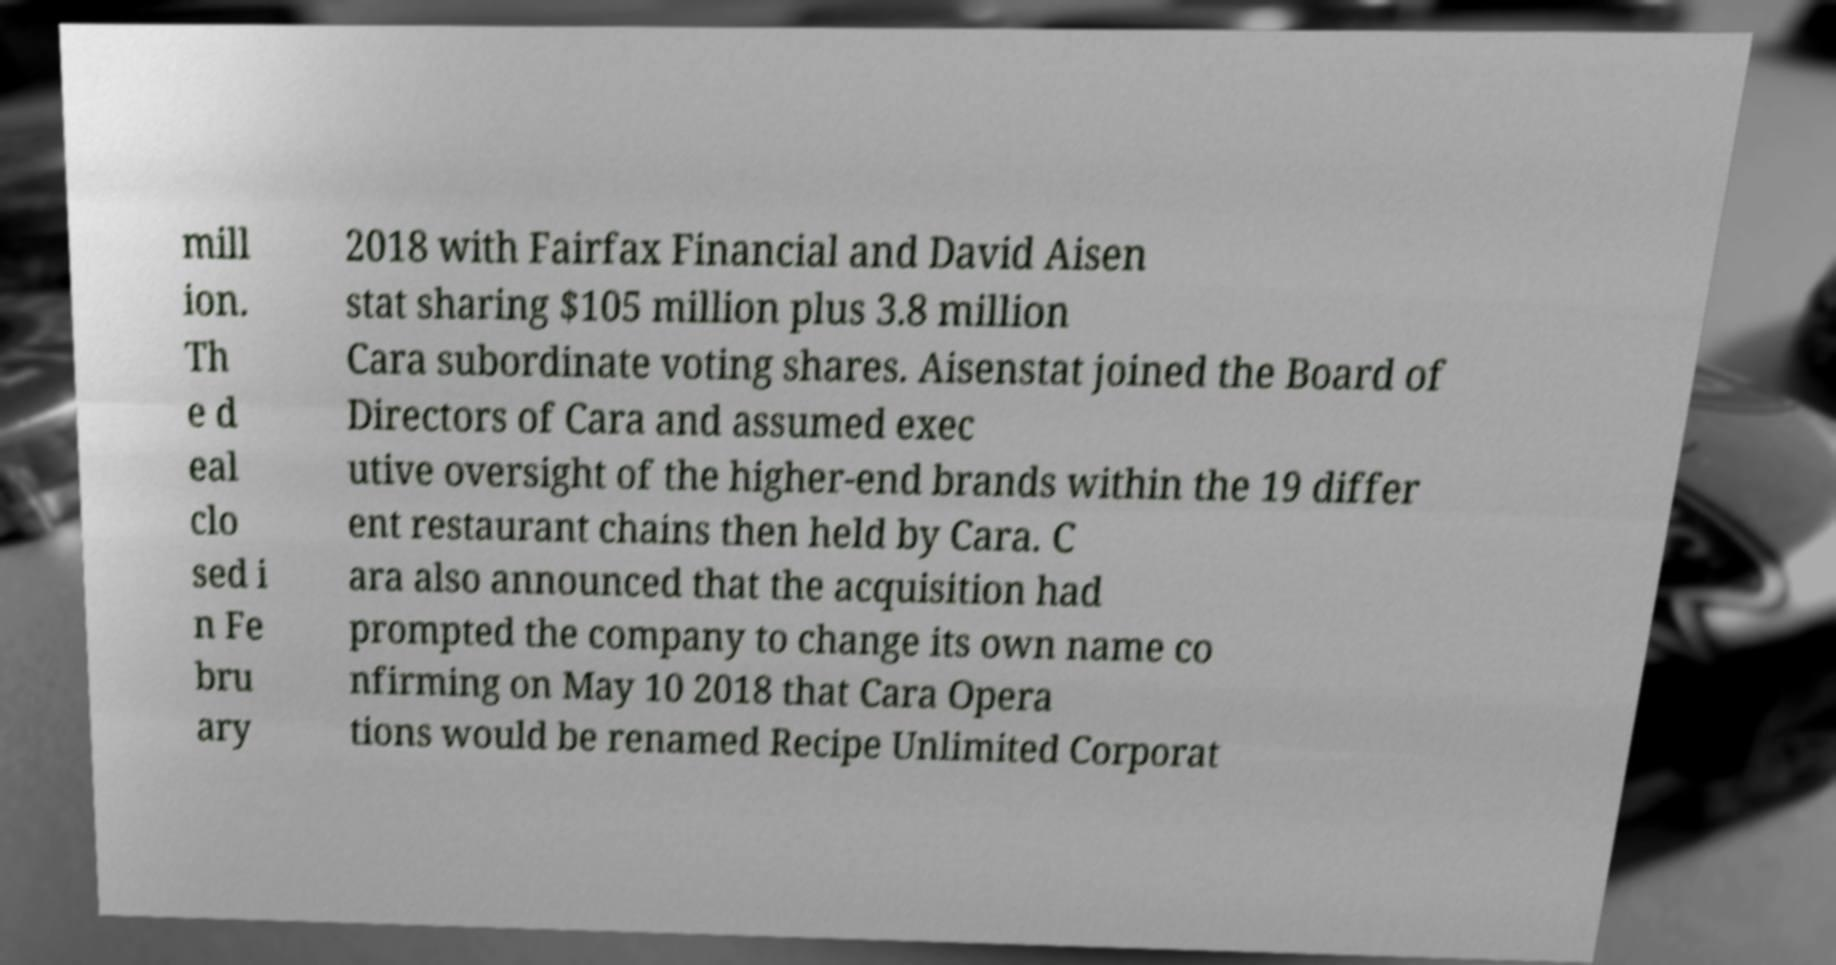Could you assist in decoding the text presented in this image and type it out clearly? mill ion. Th e d eal clo sed i n Fe bru ary 2018 with Fairfax Financial and David Aisen stat sharing $105 million plus 3.8 million Cara subordinate voting shares. Aisenstat joined the Board of Directors of Cara and assumed exec utive oversight of the higher-end brands within the 19 differ ent restaurant chains then held by Cara. C ara also announced that the acquisition had prompted the company to change its own name co nfirming on May 10 2018 that Cara Opera tions would be renamed Recipe Unlimited Corporat 